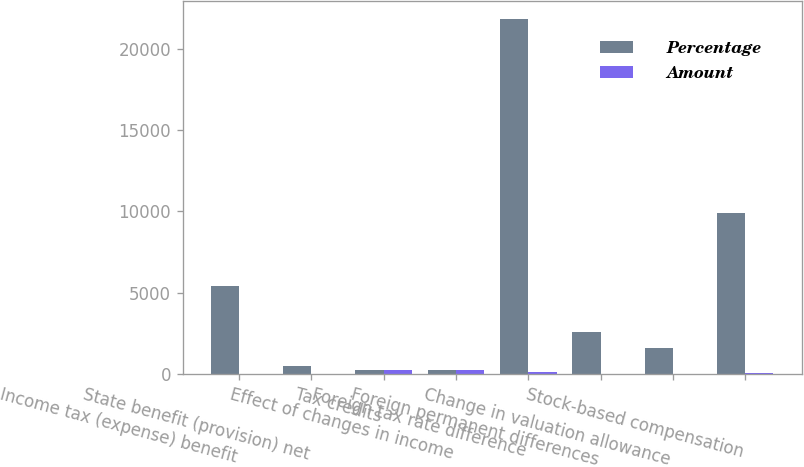Convert chart to OTSL. <chart><loc_0><loc_0><loc_500><loc_500><stacked_bar_chart><ecel><fcel>Income tax (expense) benefit<fcel>State benefit (provision) net<fcel>Tax credits<fcel>Effect of changes in income<fcel>Foreign tax rate difference<fcel>Foreign permanent differences<fcel>Change in valuation allowance<fcel>Stock-based compensation<nl><fcel>Percentage<fcel>5407<fcel>474<fcel>225.2<fcel>225.2<fcel>21829<fcel>2598<fcel>1632<fcel>9924<nl><fcel>Amount<fcel>31.54<fcel>2.77<fcel>221.95<fcel>228.45<fcel>127.32<fcel>15.15<fcel>9.52<fcel>57.88<nl></chart> 